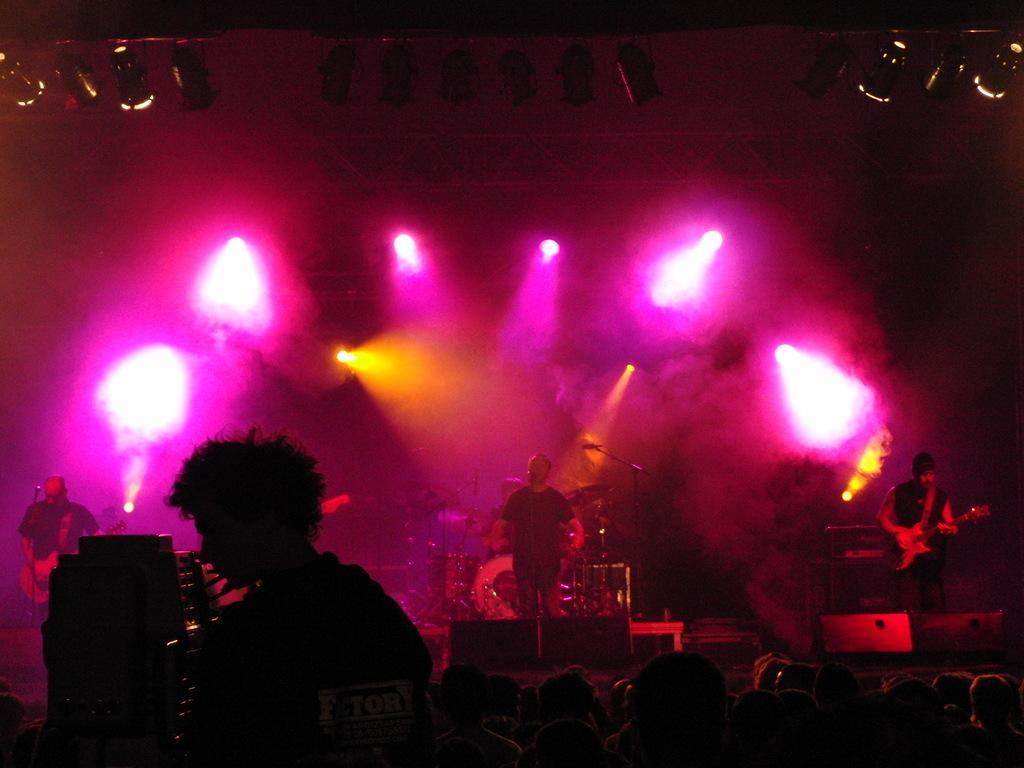What is happening with the group of people in the image? There is a group of people standing on the floor, and some people are on a stage. What are the people on the stage doing? The people on the stage are holding musical instruments and playing them. Can you describe the people on the stage? The people on the stage are musicians, as they are playing musical instruments. What type of pan can be seen being used by the people on the stage? There is no pan present in the image; the people on the stage are playing musical instruments. 